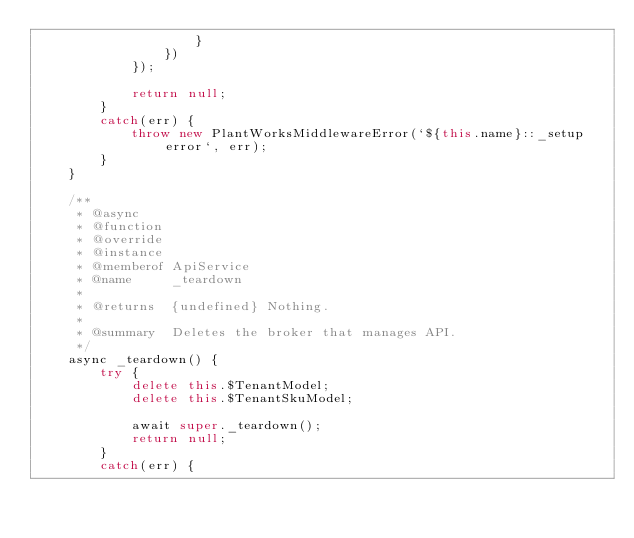<code> <loc_0><loc_0><loc_500><loc_500><_JavaScript_>					}
				})
			});

			return null;
		}
		catch(err) {
			throw new PlantWorksMiddlewareError(`${this.name}::_setup error`, err);
		}
	}

	/**
	 * @async
	 * @function
	 * @override
	 * @instance
	 * @memberof ApiService
	 * @name     _teardown
	 *
	 * @returns  {undefined} Nothing.
	 *
	 * @summary  Deletes the broker that manages API.
	 */
	async _teardown() {
		try {
			delete this.$TenantModel;
			delete this.$TenantSkuModel;

			await super._teardown();
			return null;
		}
		catch(err) {</code> 